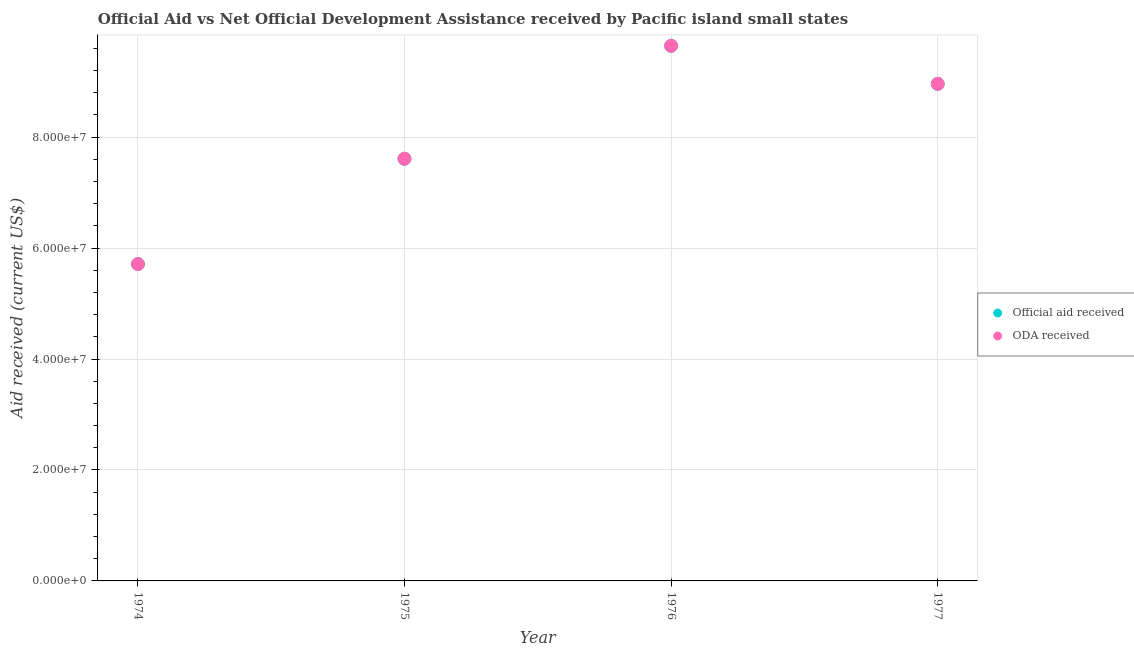How many different coloured dotlines are there?
Your response must be concise. 2. Is the number of dotlines equal to the number of legend labels?
Keep it short and to the point. Yes. What is the official aid received in 1975?
Your response must be concise. 7.61e+07. Across all years, what is the maximum oda received?
Your answer should be compact. 9.65e+07. Across all years, what is the minimum official aid received?
Offer a terse response. 5.71e+07. In which year was the official aid received maximum?
Your response must be concise. 1976. In which year was the official aid received minimum?
Offer a terse response. 1974. What is the total oda received in the graph?
Offer a terse response. 3.19e+08. What is the difference between the oda received in 1975 and that in 1976?
Keep it short and to the point. -2.04e+07. What is the difference between the oda received in 1976 and the official aid received in 1977?
Offer a terse response. 6.86e+06. What is the average official aid received per year?
Your response must be concise. 7.98e+07. In the year 1974, what is the difference between the oda received and official aid received?
Provide a short and direct response. 0. What is the ratio of the oda received in 1974 to that in 1975?
Offer a very short reply. 0.75. Is the official aid received in 1974 less than that in 1977?
Keep it short and to the point. Yes. Is the difference between the official aid received in 1974 and 1975 greater than the difference between the oda received in 1974 and 1975?
Offer a terse response. No. What is the difference between the highest and the second highest oda received?
Provide a short and direct response. 6.86e+06. What is the difference between the highest and the lowest official aid received?
Your answer should be compact. 3.94e+07. Is the sum of the oda received in 1974 and 1975 greater than the maximum official aid received across all years?
Ensure brevity in your answer.  Yes. Is the official aid received strictly less than the oda received over the years?
Offer a terse response. No. How many years are there in the graph?
Ensure brevity in your answer.  4. What is the difference between two consecutive major ticks on the Y-axis?
Provide a succinct answer. 2.00e+07. Does the graph contain any zero values?
Your answer should be very brief. No. Does the graph contain grids?
Your answer should be very brief. Yes. How many legend labels are there?
Provide a short and direct response. 2. What is the title of the graph?
Keep it short and to the point. Official Aid vs Net Official Development Assistance received by Pacific island small states . Does "Export" appear as one of the legend labels in the graph?
Your answer should be compact. No. What is the label or title of the X-axis?
Keep it short and to the point. Year. What is the label or title of the Y-axis?
Offer a terse response. Aid received (current US$). What is the Aid received (current US$) of Official aid received in 1974?
Your response must be concise. 5.71e+07. What is the Aid received (current US$) in ODA received in 1974?
Give a very brief answer. 5.71e+07. What is the Aid received (current US$) in Official aid received in 1975?
Offer a very short reply. 7.61e+07. What is the Aid received (current US$) in ODA received in 1975?
Your answer should be compact. 7.61e+07. What is the Aid received (current US$) of Official aid received in 1976?
Your response must be concise. 9.65e+07. What is the Aid received (current US$) in ODA received in 1976?
Your answer should be compact. 9.65e+07. What is the Aid received (current US$) in Official aid received in 1977?
Provide a succinct answer. 8.96e+07. What is the Aid received (current US$) of ODA received in 1977?
Your answer should be compact. 8.96e+07. Across all years, what is the maximum Aid received (current US$) of Official aid received?
Your answer should be very brief. 9.65e+07. Across all years, what is the maximum Aid received (current US$) of ODA received?
Offer a very short reply. 9.65e+07. Across all years, what is the minimum Aid received (current US$) in Official aid received?
Provide a short and direct response. 5.71e+07. Across all years, what is the minimum Aid received (current US$) of ODA received?
Ensure brevity in your answer.  5.71e+07. What is the total Aid received (current US$) of Official aid received in the graph?
Provide a succinct answer. 3.19e+08. What is the total Aid received (current US$) of ODA received in the graph?
Give a very brief answer. 3.19e+08. What is the difference between the Aid received (current US$) in Official aid received in 1974 and that in 1975?
Make the answer very short. -1.90e+07. What is the difference between the Aid received (current US$) in ODA received in 1974 and that in 1975?
Offer a very short reply. -1.90e+07. What is the difference between the Aid received (current US$) in Official aid received in 1974 and that in 1976?
Provide a short and direct response. -3.94e+07. What is the difference between the Aid received (current US$) of ODA received in 1974 and that in 1976?
Offer a very short reply. -3.94e+07. What is the difference between the Aid received (current US$) in Official aid received in 1974 and that in 1977?
Your response must be concise. -3.25e+07. What is the difference between the Aid received (current US$) in ODA received in 1974 and that in 1977?
Ensure brevity in your answer.  -3.25e+07. What is the difference between the Aid received (current US$) in Official aid received in 1975 and that in 1976?
Offer a very short reply. -2.04e+07. What is the difference between the Aid received (current US$) of ODA received in 1975 and that in 1976?
Your answer should be compact. -2.04e+07. What is the difference between the Aid received (current US$) of Official aid received in 1975 and that in 1977?
Provide a succinct answer. -1.35e+07. What is the difference between the Aid received (current US$) in ODA received in 1975 and that in 1977?
Offer a very short reply. -1.35e+07. What is the difference between the Aid received (current US$) of Official aid received in 1976 and that in 1977?
Give a very brief answer. 6.86e+06. What is the difference between the Aid received (current US$) in ODA received in 1976 and that in 1977?
Make the answer very short. 6.86e+06. What is the difference between the Aid received (current US$) of Official aid received in 1974 and the Aid received (current US$) of ODA received in 1975?
Offer a very short reply. -1.90e+07. What is the difference between the Aid received (current US$) in Official aid received in 1974 and the Aid received (current US$) in ODA received in 1976?
Offer a terse response. -3.94e+07. What is the difference between the Aid received (current US$) of Official aid received in 1974 and the Aid received (current US$) of ODA received in 1977?
Provide a succinct answer. -3.25e+07. What is the difference between the Aid received (current US$) in Official aid received in 1975 and the Aid received (current US$) in ODA received in 1976?
Provide a short and direct response. -2.04e+07. What is the difference between the Aid received (current US$) of Official aid received in 1975 and the Aid received (current US$) of ODA received in 1977?
Make the answer very short. -1.35e+07. What is the difference between the Aid received (current US$) in Official aid received in 1976 and the Aid received (current US$) in ODA received in 1977?
Offer a very short reply. 6.86e+06. What is the average Aid received (current US$) in Official aid received per year?
Your answer should be compact. 7.98e+07. What is the average Aid received (current US$) of ODA received per year?
Provide a short and direct response. 7.98e+07. In the year 1976, what is the difference between the Aid received (current US$) of Official aid received and Aid received (current US$) of ODA received?
Offer a very short reply. 0. What is the ratio of the Aid received (current US$) in Official aid received in 1974 to that in 1975?
Provide a succinct answer. 0.75. What is the ratio of the Aid received (current US$) in ODA received in 1974 to that in 1975?
Your answer should be compact. 0.75. What is the ratio of the Aid received (current US$) of Official aid received in 1974 to that in 1976?
Offer a terse response. 0.59. What is the ratio of the Aid received (current US$) of ODA received in 1974 to that in 1976?
Provide a succinct answer. 0.59. What is the ratio of the Aid received (current US$) in Official aid received in 1974 to that in 1977?
Your answer should be compact. 0.64. What is the ratio of the Aid received (current US$) of ODA received in 1974 to that in 1977?
Your response must be concise. 0.64. What is the ratio of the Aid received (current US$) of Official aid received in 1975 to that in 1976?
Make the answer very short. 0.79. What is the ratio of the Aid received (current US$) in ODA received in 1975 to that in 1976?
Offer a very short reply. 0.79. What is the ratio of the Aid received (current US$) in Official aid received in 1975 to that in 1977?
Offer a terse response. 0.85. What is the ratio of the Aid received (current US$) of ODA received in 1975 to that in 1977?
Your answer should be compact. 0.85. What is the ratio of the Aid received (current US$) in Official aid received in 1976 to that in 1977?
Provide a short and direct response. 1.08. What is the ratio of the Aid received (current US$) in ODA received in 1976 to that in 1977?
Offer a terse response. 1.08. What is the difference between the highest and the second highest Aid received (current US$) in Official aid received?
Your response must be concise. 6.86e+06. What is the difference between the highest and the second highest Aid received (current US$) of ODA received?
Your answer should be very brief. 6.86e+06. What is the difference between the highest and the lowest Aid received (current US$) of Official aid received?
Your answer should be compact. 3.94e+07. What is the difference between the highest and the lowest Aid received (current US$) in ODA received?
Keep it short and to the point. 3.94e+07. 